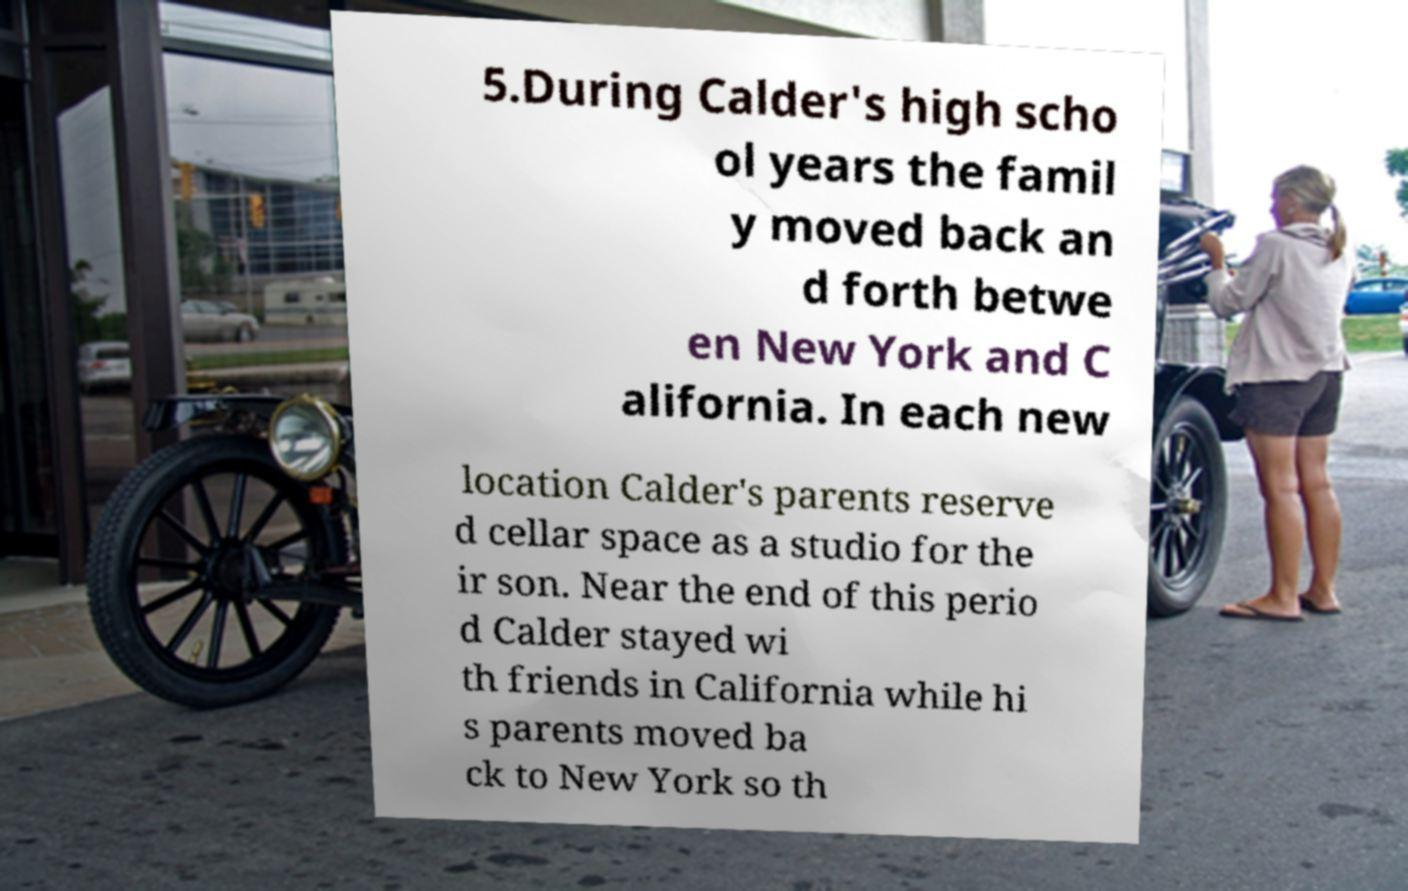What messages or text are displayed in this image? I need them in a readable, typed format. 5.During Calder's high scho ol years the famil y moved back an d forth betwe en New York and C alifornia. In each new location Calder's parents reserve d cellar space as a studio for the ir son. Near the end of this perio d Calder stayed wi th friends in California while hi s parents moved ba ck to New York so th 